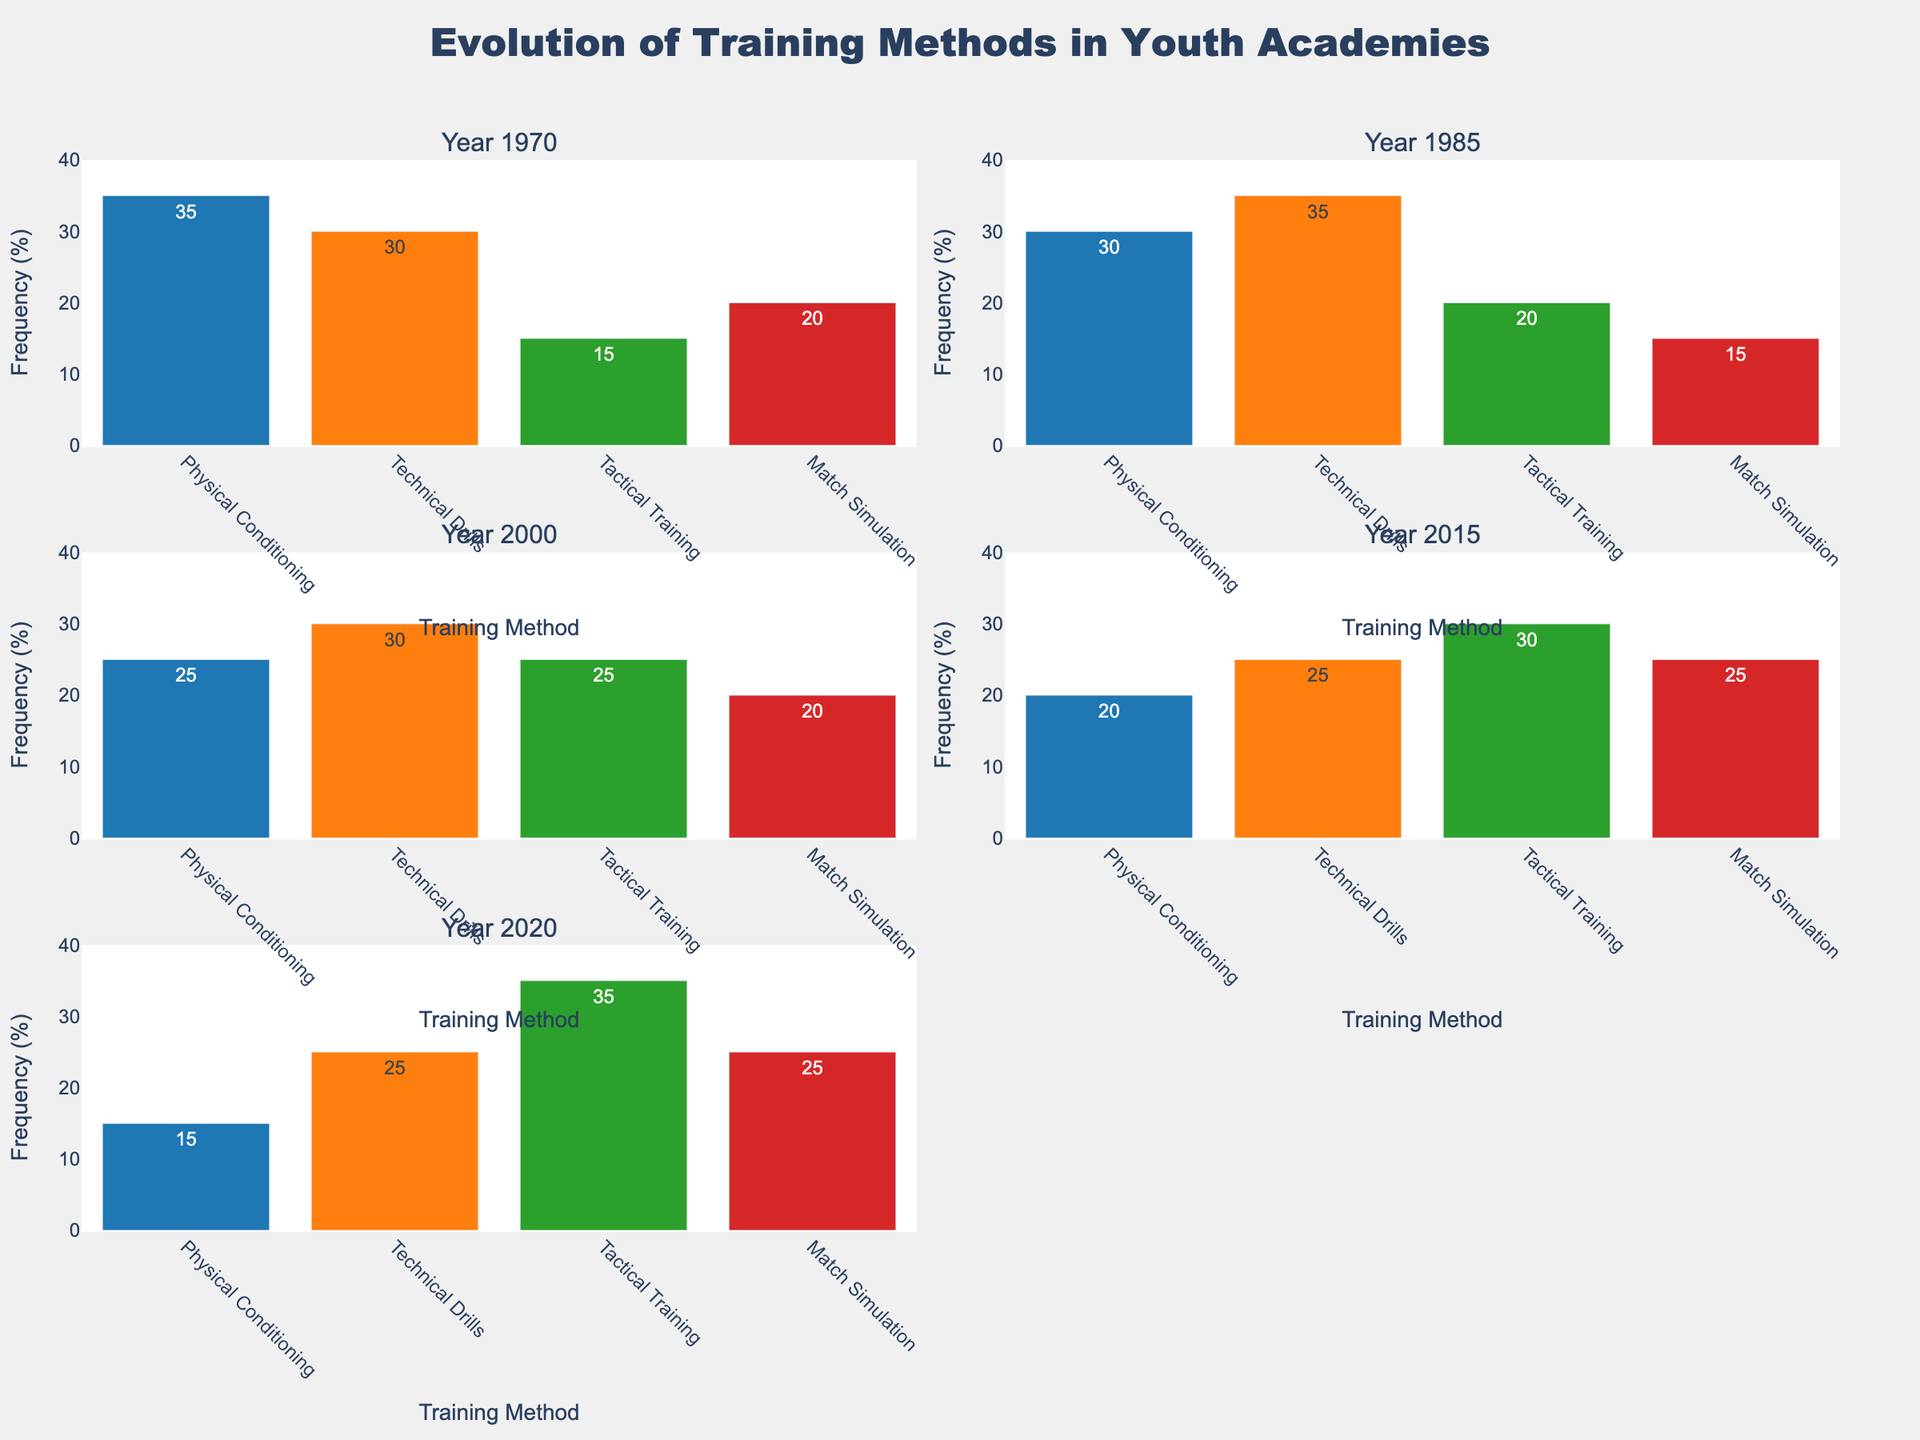What's the title of the figure? The title is usually displayed prominently above the visual. In this case, it's at the top of the figure.
Answer: Evolution of Training Methods in Youth Academies How many total subplots are there in the figure? The subplots are arranged in a 3x2 grid. Counting each individual plot, there are 6 subplots.
Answer: 6 subplots Which training method had the highest frequency in 2020? Look at the 2020 subplot and identify the bar with the highest frequency value. Tactical Training has the highest frequency.
Answer: Tactical Training Compare the frequency of Physical Conditioning in 1970 and 2020. Which year had a higher frequency and by how much? In 1970, the frequency is 35. In 2020, the frequency is 15. The difference is calculated as 35 - 15 = 20, with 1970 having a higher frequency.
Answer: 1970 by 20 Which year had the lowest frequency for Match Simulation? Inspect each subplot for Match Simulation. The lowest value is in 1985 with a frequency of 15.
Answer: 1985 What was the total frequency of Technical Drills in all the displayed years combined? Adding up the frequencies for Technical Drills: 30 (1970) + 35 (1985) + 30 (2000) + 25 (2015) + 25 (2020) = 145.
Answer: 145 What is the trend observed in the frequency of Tactical Training from 1970 to 2020? By examining the values for Tactical Training over the years, we see an increasing trend: 15 (1970), 20 (1985), 25 (2000), 30 (2015), 35 (2020).
Answer: Increasing trend Which training method had the most consistent frequency across all the years? Calculate standard deviation (or look for similar values visually) for each method. Technical Drills ranges between 25-35, which is the most consistent range among all methods.
Answer: Technical Drills Compare the frequencies of Match Simulation in 1970 and 2015. Are they equal or different? Match Simulation frequency in 1970 is 20 and in 2015 is 25. By comparing, we see they are different.
Answer: Different 